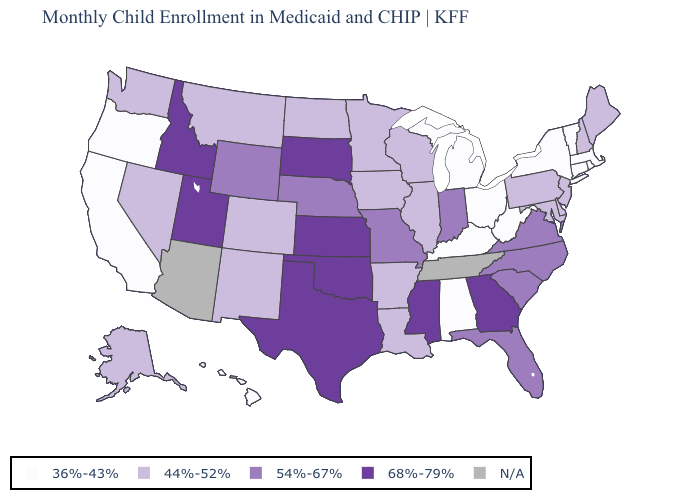What is the value of Alaska?
Quick response, please. 44%-52%. Which states have the highest value in the USA?
Answer briefly. Georgia, Idaho, Kansas, Mississippi, Oklahoma, South Dakota, Texas, Utah. What is the value of Massachusetts?
Keep it brief. 36%-43%. Does Montana have the lowest value in the USA?
Concise answer only. No. Which states have the highest value in the USA?
Concise answer only. Georgia, Idaho, Kansas, Mississippi, Oklahoma, South Dakota, Texas, Utah. Does the first symbol in the legend represent the smallest category?
Give a very brief answer. Yes. Name the states that have a value in the range 68%-79%?
Answer briefly. Georgia, Idaho, Kansas, Mississippi, Oklahoma, South Dakota, Texas, Utah. What is the value of Arizona?
Write a very short answer. N/A. Does the map have missing data?
Write a very short answer. Yes. Among the states that border Texas , which have the highest value?
Quick response, please. Oklahoma. Among the states that border Illinois , does Iowa have the lowest value?
Be succinct. No. Does Connecticut have the highest value in the USA?
Keep it brief. No. Which states have the lowest value in the USA?
Answer briefly. Alabama, California, Connecticut, Hawaii, Kentucky, Massachusetts, Michigan, New York, Ohio, Oregon, Rhode Island, Vermont, West Virginia. What is the lowest value in the South?
Short answer required. 36%-43%. 